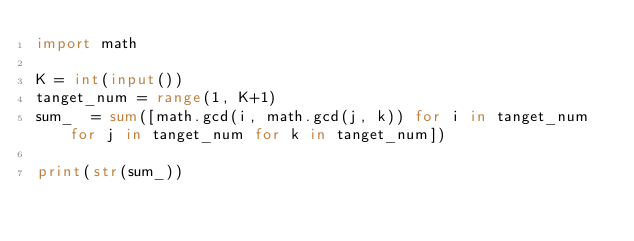Convert code to text. <code><loc_0><loc_0><loc_500><loc_500><_Python_>import math

K = int(input())
tanget_num = range(1, K+1)
sum_  = sum([math.gcd(i, math.gcd(j, k)) for i in tanget_num for j in tanget_num for k in tanget_num])

print(str(sum_))</code> 